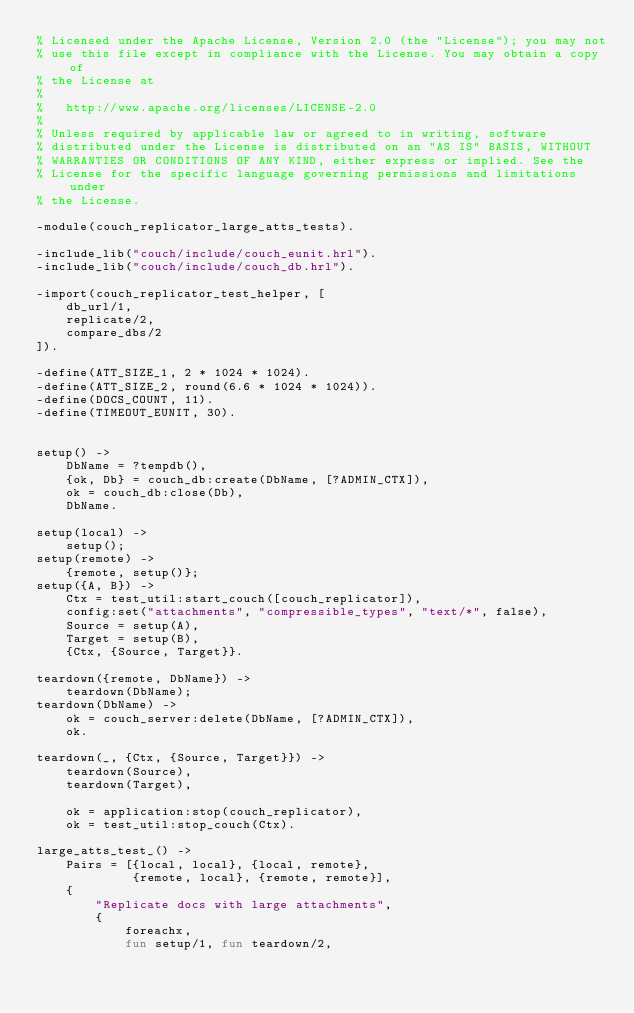<code> <loc_0><loc_0><loc_500><loc_500><_Erlang_>% Licensed under the Apache License, Version 2.0 (the "License"); you may not
% use this file except in compliance with the License. You may obtain a copy of
% the License at
%
%   http://www.apache.org/licenses/LICENSE-2.0
%
% Unless required by applicable law or agreed to in writing, software
% distributed under the License is distributed on an "AS IS" BASIS, WITHOUT
% WARRANTIES OR CONDITIONS OF ANY KIND, either express or implied. See the
% License for the specific language governing permissions and limitations under
% the License.

-module(couch_replicator_large_atts_tests).

-include_lib("couch/include/couch_eunit.hrl").
-include_lib("couch/include/couch_db.hrl").

-import(couch_replicator_test_helper, [
    db_url/1,
    replicate/2,
    compare_dbs/2
]).

-define(ATT_SIZE_1, 2 * 1024 * 1024).
-define(ATT_SIZE_2, round(6.6 * 1024 * 1024)).
-define(DOCS_COUNT, 11).
-define(TIMEOUT_EUNIT, 30).


setup() ->
    DbName = ?tempdb(),
    {ok, Db} = couch_db:create(DbName, [?ADMIN_CTX]),
    ok = couch_db:close(Db),
    DbName.

setup(local) ->
    setup();
setup(remote) ->
    {remote, setup()};
setup({A, B}) ->
    Ctx = test_util:start_couch([couch_replicator]),
    config:set("attachments", "compressible_types", "text/*", false),
    Source = setup(A),
    Target = setup(B),
    {Ctx, {Source, Target}}.

teardown({remote, DbName}) ->
    teardown(DbName);
teardown(DbName) ->
    ok = couch_server:delete(DbName, [?ADMIN_CTX]),
    ok.

teardown(_, {Ctx, {Source, Target}}) ->
    teardown(Source),
    teardown(Target),

    ok = application:stop(couch_replicator),
    ok = test_util:stop_couch(Ctx).

large_atts_test_() ->
    Pairs = [{local, local}, {local, remote},
             {remote, local}, {remote, remote}],
    {
        "Replicate docs with large attachments",
        {
            foreachx,
            fun setup/1, fun teardown/2,</code> 